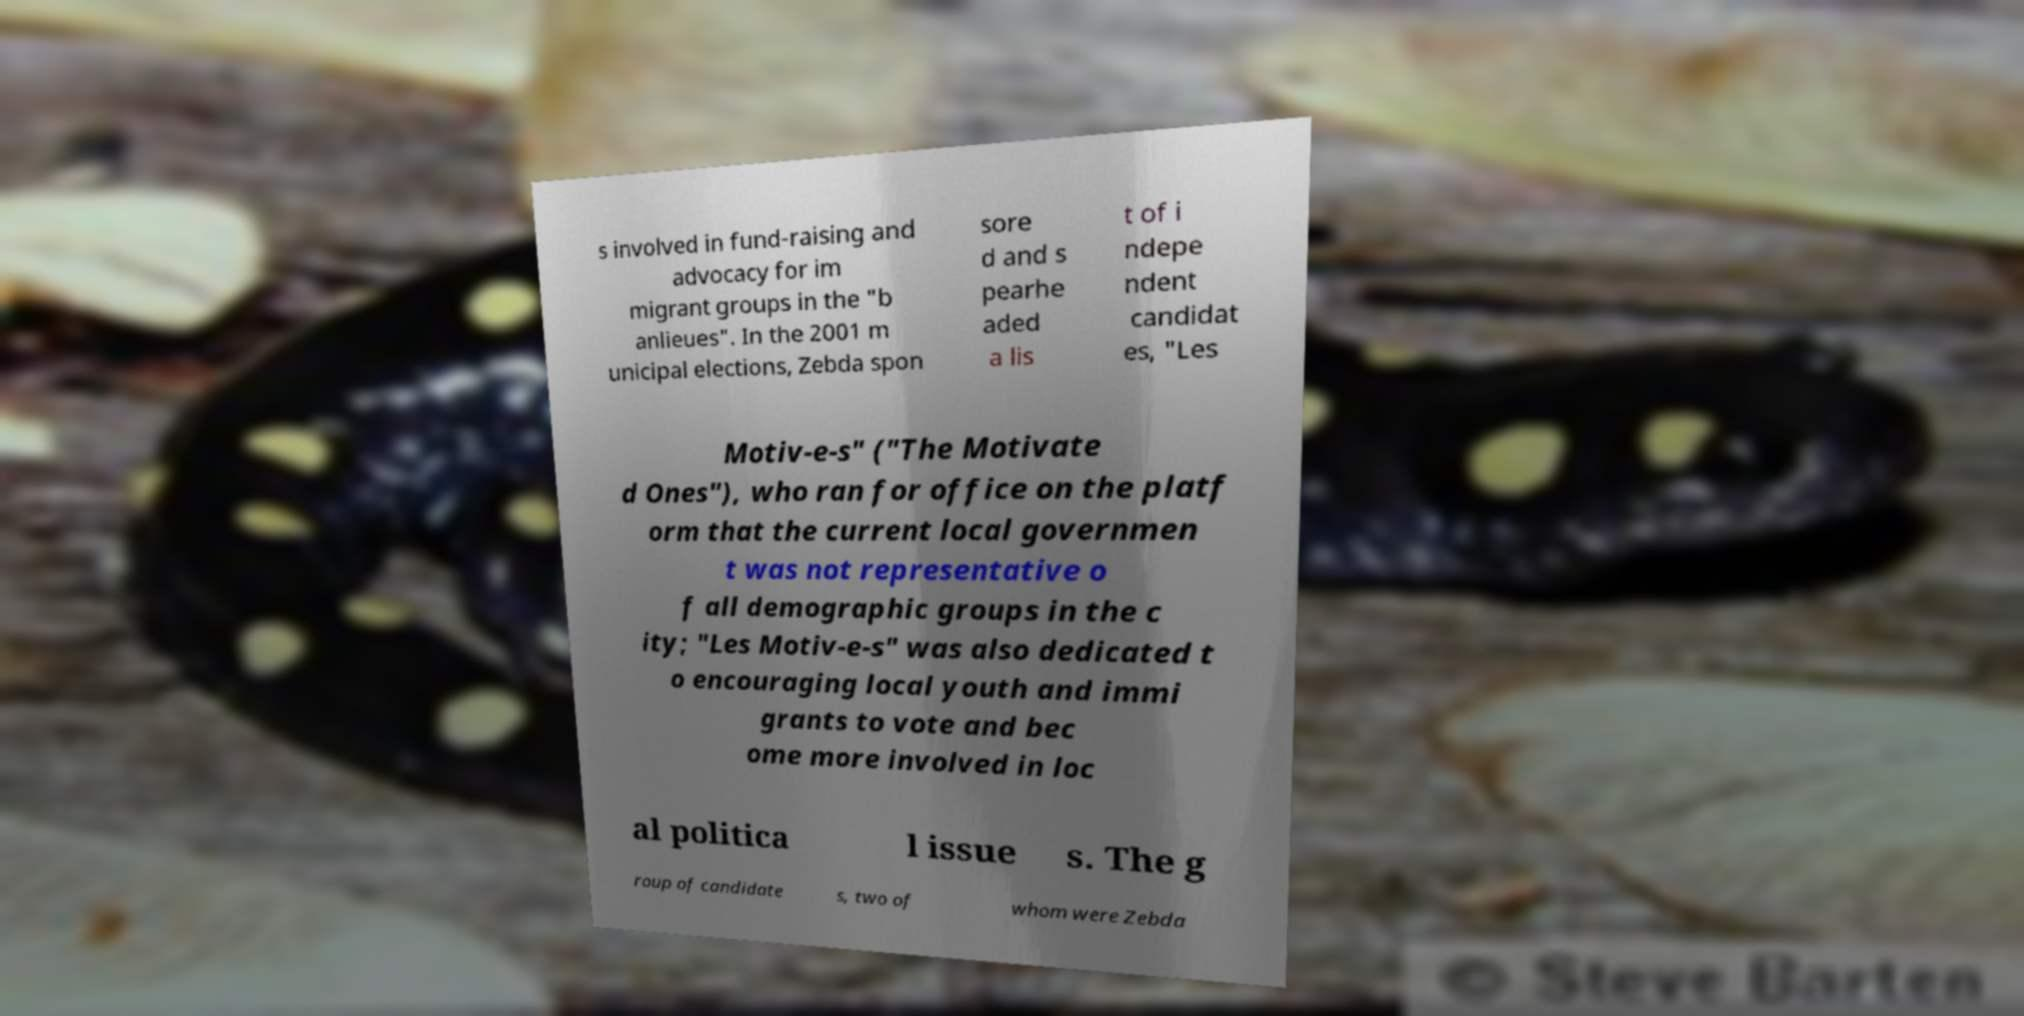What messages or text are displayed in this image? I need them in a readable, typed format. s involved in fund-raising and advocacy for im migrant groups in the "b anlieues". In the 2001 m unicipal elections, Zebda spon sore d and s pearhe aded a lis t of i ndepe ndent candidat es, "Les Motiv-e-s" ("The Motivate d Ones"), who ran for office on the platf orm that the current local governmen t was not representative o f all demographic groups in the c ity; "Les Motiv-e-s" was also dedicated t o encouraging local youth and immi grants to vote and bec ome more involved in loc al politica l issue s. The g roup of candidate s, two of whom were Zebda 